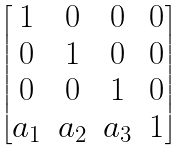Convert formula to latex. <formula><loc_0><loc_0><loc_500><loc_500>\begin{bmatrix} 1 & 0 & 0 & 0 \\ 0 & 1 & 0 & 0 \\ 0 & 0 & 1 & 0 \\ a _ { 1 } & a _ { 2 } & a _ { 3 } & 1 \end{bmatrix}</formula> 